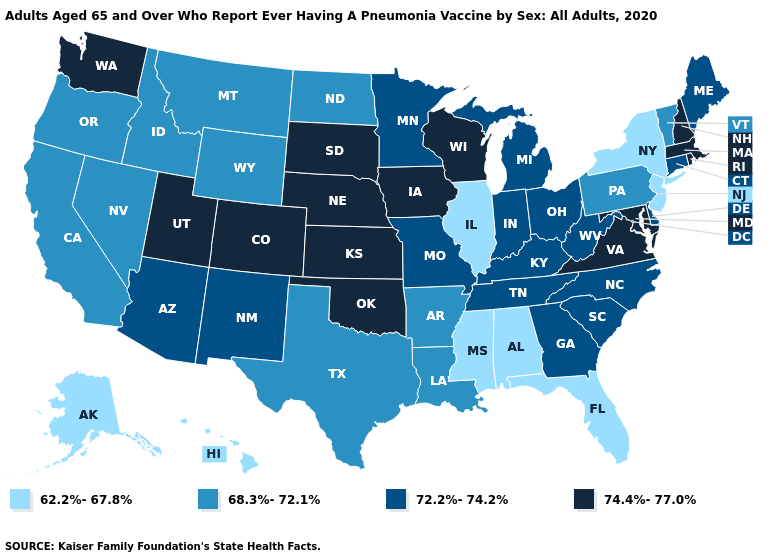What is the lowest value in the MidWest?
Quick response, please. 62.2%-67.8%. Name the states that have a value in the range 74.4%-77.0%?
Answer briefly. Colorado, Iowa, Kansas, Maryland, Massachusetts, Nebraska, New Hampshire, Oklahoma, Rhode Island, South Dakota, Utah, Virginia, Washington, Wisconsin. Name the states that have a value in the range 62.2%-67.8%?
Concise answer only. Alabama, Alaska, Florida, Hawaii, Illinois, Mississippi, New Jersey, New York. Name the states that have a value in the range 62.2%-67.8%?
Give a very brief answer. Alabama, Alaska, Florida, Hawaii, Illinois, Mississippi, New Jersey, New York. Does Washington have a higher value than Georgia?
Concise answer only. Yes. What is the value of New York?
Concise answer only. 62.2%-67.8%. Which states have the highest value in the USA?
Give a very brief answer. Colorado, Iowa, Kansas, Maryland, Massachusetts, Nebraska, New Hampshire, Oklahoma, Rhode Island, South Dakota, Utah, Virginia, Washington, Wisconsin. What is the highest value in the South ?
Be succinct. 74.4%-77.0%. Does the map have missing data?
Write a very short answer. No. Which states have the lowest value in the USA?
Be succinct. Alabama, Alaska, Florida, Hawaii, Illinois, Mississippi, New Jersey, New York. What is the value of Nevada?
Write a very short answer. 68.3%-72.1%. What is the value of Kansas?
Quick response, please. 74.4%-77.0%. What is the value of Illinois?
Give a very brief answer. 62.2%-67.8%. Does Nevada have a higher value than Mississippi?
Short answer required. Yes. What is the value of Maine?
Short answer required. 72.2%-74.2%. 